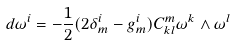Convert formula to latex. <formula><loc_0><loc_0><loc_500><loc_500>d \omega ^ { i } = - \frac { 1 } { 2 } ( 2 \delta _ { m } ^ { i } - g _ { m } ^ { i } ) C _ { k l } ^ { m } \omega ^ { k } \wedge \omega ^ { l }</formula> 